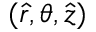<formula> <loc_0><loc_0><loc_500><loc_500>( \hat { r } , \theta , \hat { z } )</formula> 